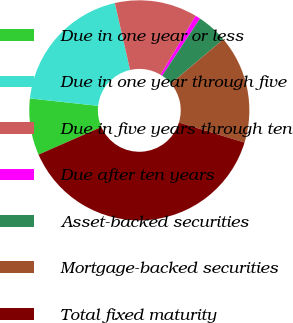<chart> <loc_0><loc_0><loc_500><loc_500><pie_chart><fcel>Due in one year or less<fcel>Due in one year through five<fcel>Due in five years through ten<fcel>Due after ten years<fcel>Asset-backed securities<fcel>Mortgage-backed securities<fcel>Total fixed maturity<nl><fcel>8.32%<fcel>19.71%<fcel>12.12%<fcel>0.74%<fcel>4.53%<fcel>15.91%<fcel>38.68%<nl></chart> 